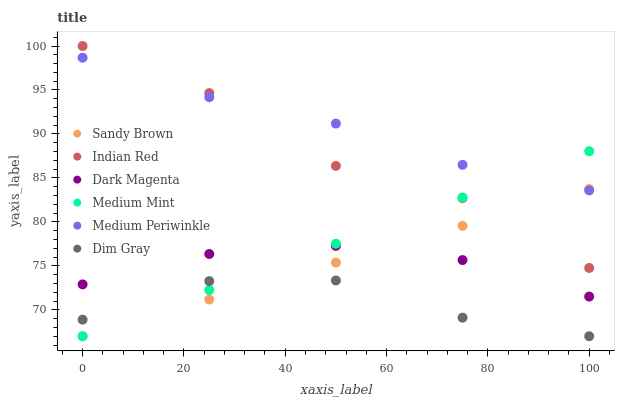Does Dim Gray have the minimum area under the curve?
Answer yes or no. Yes. Does Medium Periwinkle have the maximum area under the curve?
Answer yes or no. Yes. Does Dark Magenta have the minimum area under the curve?
Answer yes or no. No. Does Dark Magenta have the maximum area under the curve?
Answer yes or no. No. Is Sandy Brown the smoothest?
Answer yes or no. Yes. Is Indian Red the roughest?
Answer yes or no. Yes. Is Dim Gray the smoothest?
Answer yes or no. No. Is Dim Gray the roughest?
Answer yes or no. No. Does Medium Mint have the lowest value?
Answer yes or no. Yes. Does Dark Magenta have the lowest value?
Answer yes or no. No. Does Indian Red have the highest value?
Answer yes or no. Yes. Does Dark Magenta have the highest value?
Answer yes or no. No. Is Dim Gray less than Dark Magenta?
Answer yes or no. Yes. Is Medium Periwinkle greater than Dim Gray?
Answer yes or no. Yes. Does Indian Red intersect Medium Periwinkle?
Answer yes or no. Yes. Is Indian Red less than Medium Periwinkle?
Answer yes or no. No. Is Indian Red greater than Medium Periwinkle?
Answer yes or no. No. Does Dim Gray intersect Dark Magenta?
Answer yes or no. No. 